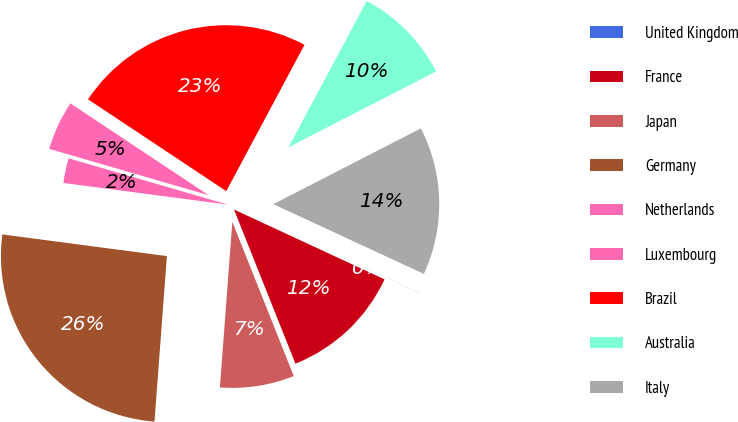Convert chart. <chart><loc_0><loc_0><loc_500><loc_500><pie_chart><fcel>United Kingdom<fcel>France<fcel>Japan<fcel>Germany<fcel>Netherlands<fcel>Luxembourg<fcel>Brazil<fcel>Australia<fcel>Italy<nl><fcel>0.01%<fcel>12.05%<fcel>7.23%<fcel>25.89%<fcel>2.42%<fcel>4.83%<fcel>23.48%<fcel>9.64%<fcel>14.45%<nl></chart> 